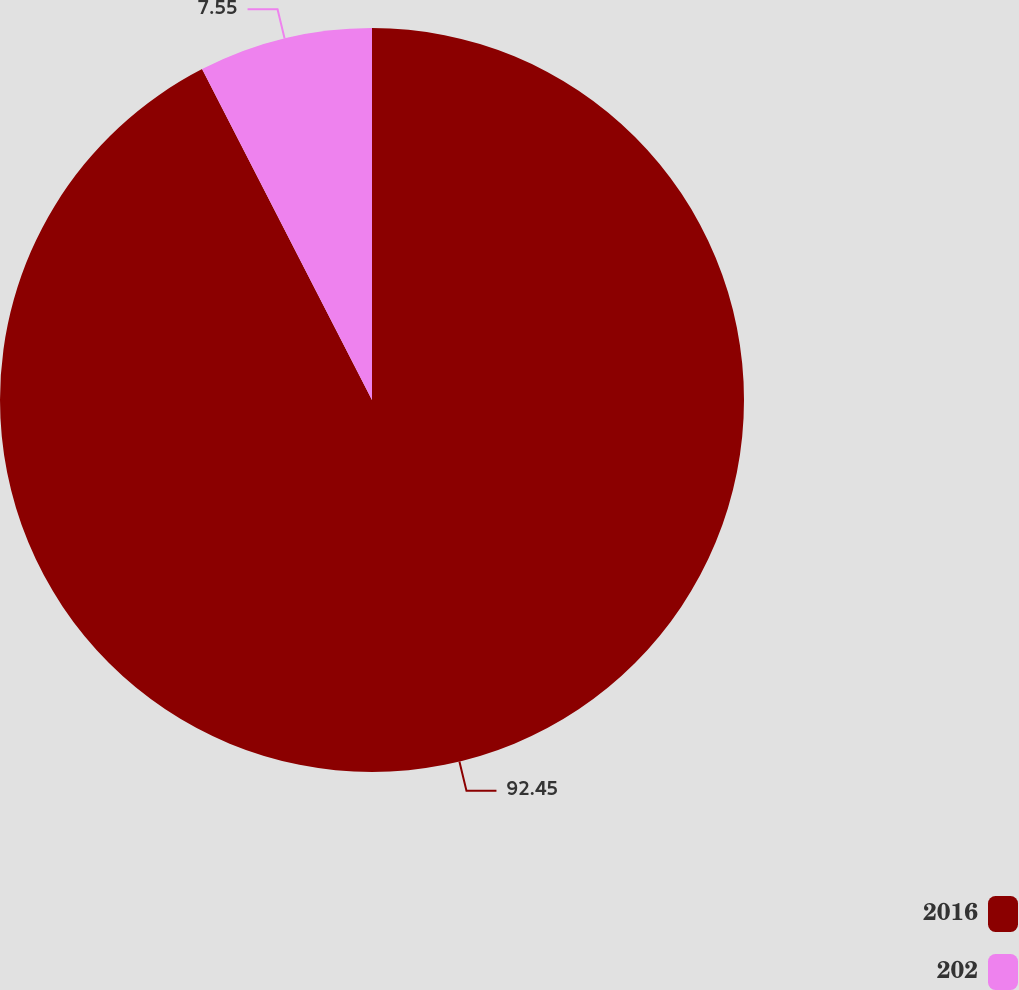Convert chart. <chart><loc_0><loc_0><loc_500><loc_500><pie_chart><fcel>2016<fcel>202<nl><fcel>92.45%<fcel>7.55%<nl></chart> 